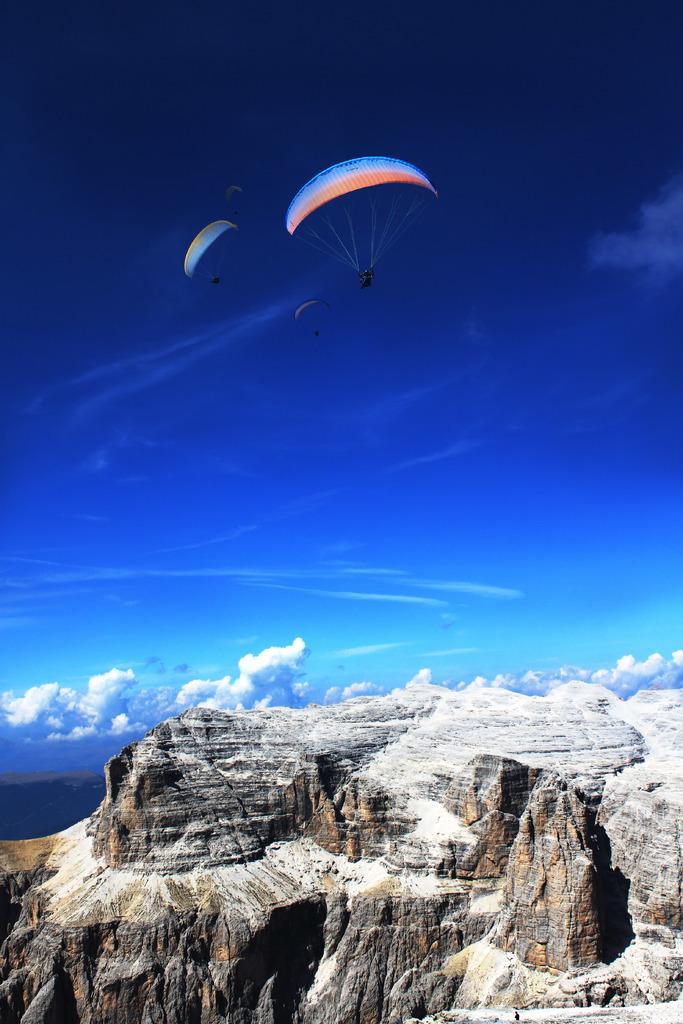Can you describe this image briefly? In the image there are two parachutes flying in the air and there is a big hill below the parachutes. 